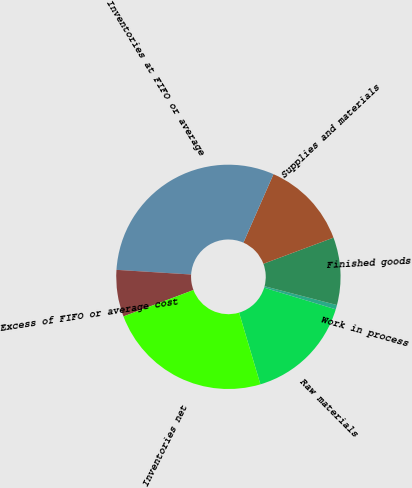Convert chart to OTSL. <chart><loc_0><loc_0><loc_500><loc_500><pie_chart><fcel>Raw materials<fcel>Work in process<fcel>Finished goods<fcel>Supplies and materials<fcel>Inventories at FIFO or average<fcel>Excess of FIFO or average cost<fcel>Inventories net<nl><fcel>15.72%<fcel>0.63%<fcel>9.73%<fcel>12.73%<fcel>30.59%<fcel>6.74%<fcel>23.86%<nl></chart> 